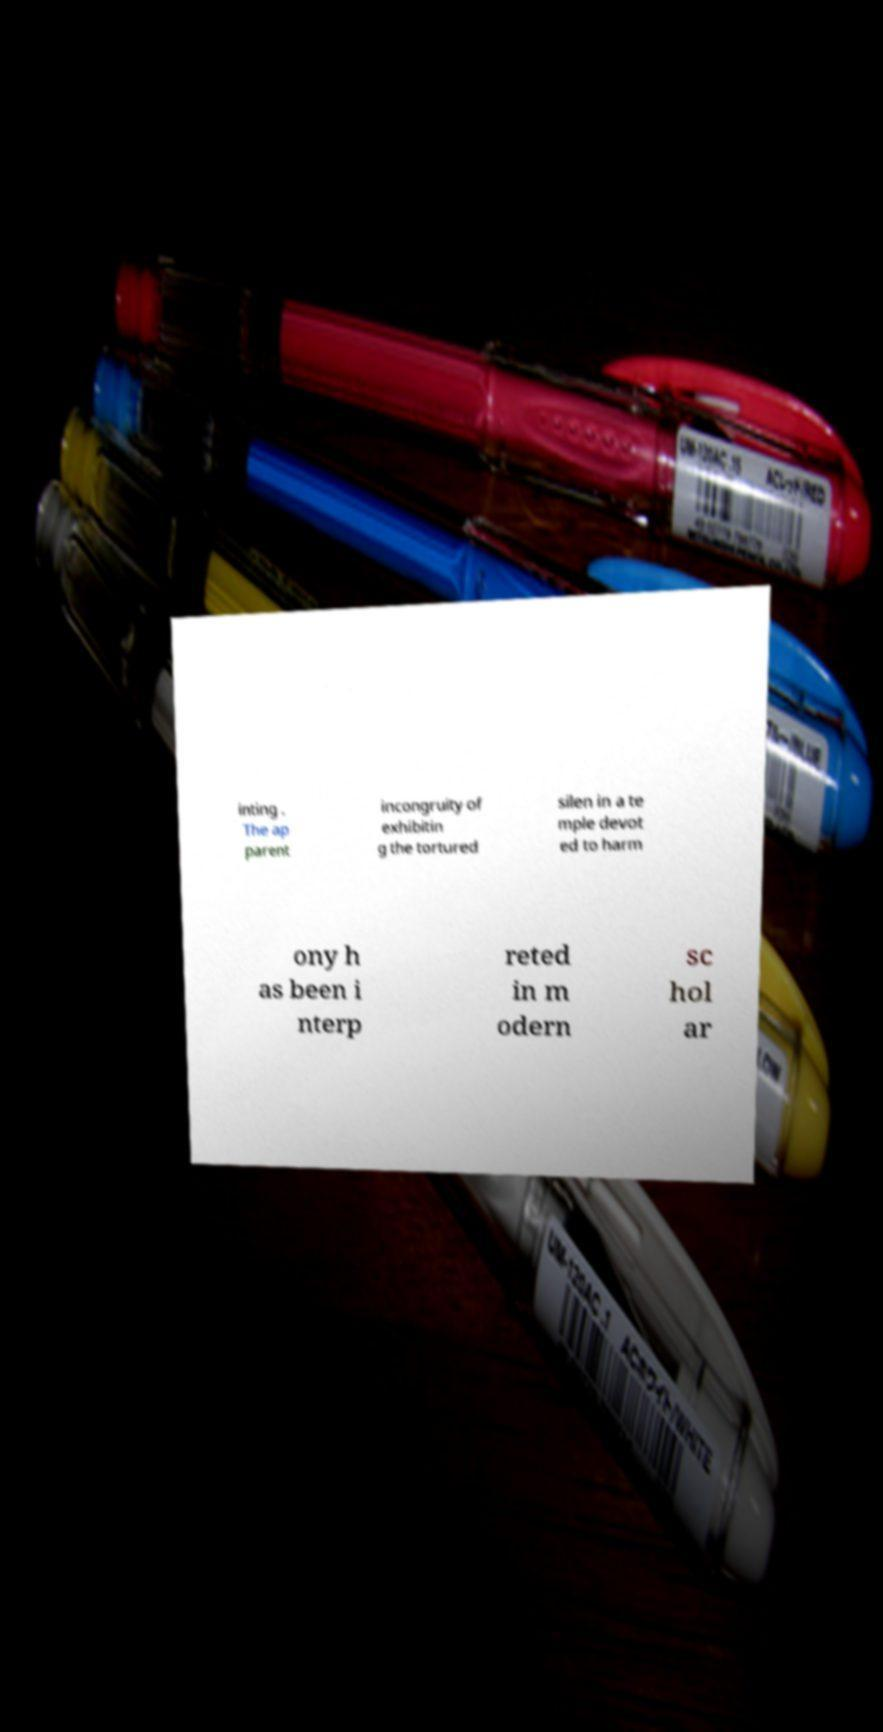What messages or text are displayed in this image? I need them in a readable, typed format. inting . The ap parent incongruity of exhibitin g the tortured silen in a te mple devot ed to harm ony h as been i nterp reted in m odern sc hol ar 